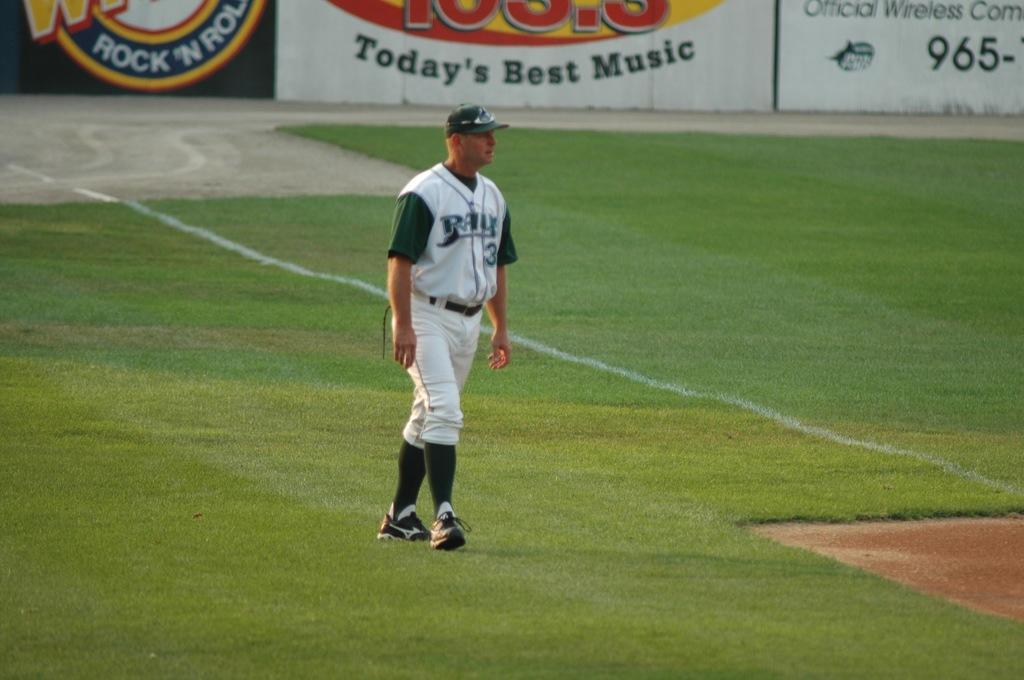Provide a one-sentence caption for the provided image. A baseball player stands in a field that is supported by a radio station with Today's best music. 